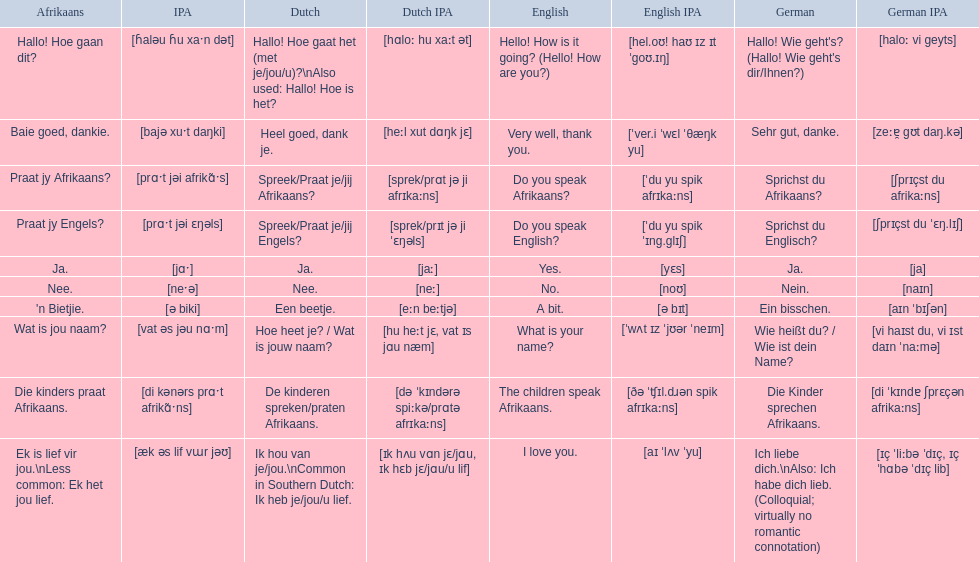How would you say the phrase the children speak afrikaans in afrikaans? Die kinders praat Afrikaans. How would you say the previous phrase in german? Die Kinder sprechen Afrikaans. 